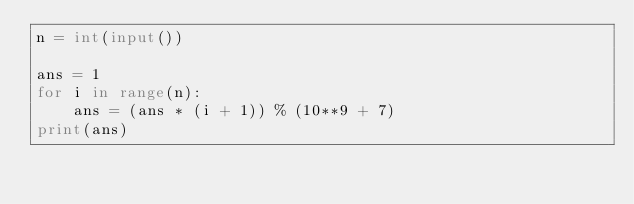Convert code to text. <code><loc_0><loc_0><loc_500><loc_500><_Python_>n = int(input())

ans = 1
for i in range(n):
    ans = (ans * (i + 1)) % (10**9 + 7)
print(ans)</code> 